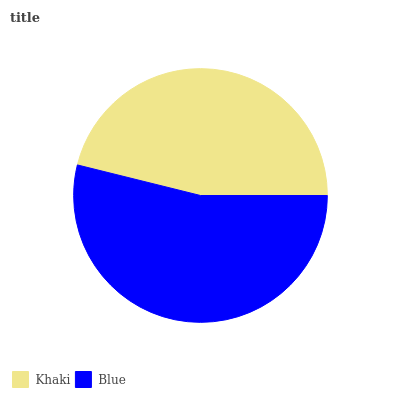Is Khaki the minimum?
Answer yes or no. Yes. Is Blue the maximum?
Answer yes or no. Yes. Is Blue the minimum?
Answer yes or no. No. Is Blue greater than Khaki?
Answer yes or no. Yes. Is Khaki less than Blue?
Answer yes or no. Yes. Is Khaki greater than Blue?
Answer yes or no. No. Is Blue less than Khaki?
Answer yes or no. No. Is Blue the high median?
Answer yes or no. Yes. Is Khaki the low median?
Answer yes or no. Yes. Is Khaki the high median?
Answer yes or no. No. Is Blue the low median?
Answer yes or no. No. 